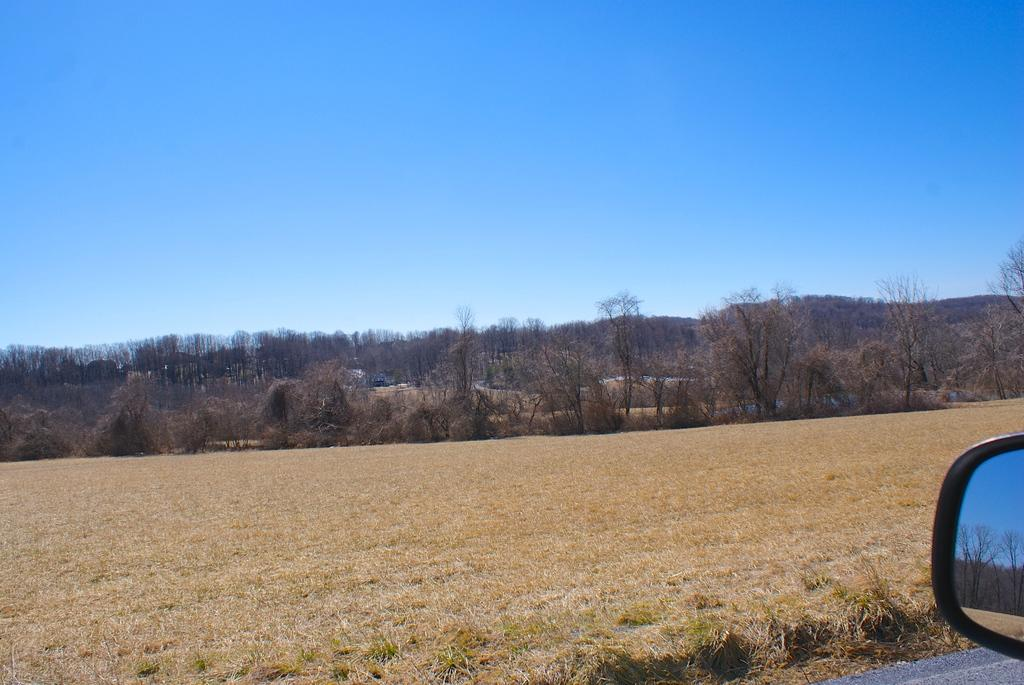What object in the image allows for reflection? There is a mirror in the image. What type of natural elements can be seen in the image? There are trees and plants in the image. What part of the natural environment is visible in the image? The sky is visible in the image. Can you hear the school bell ringing in the image? There is no reference to a school or any sounds in the image, so it's not possible to determine if a school bell is ringing. 